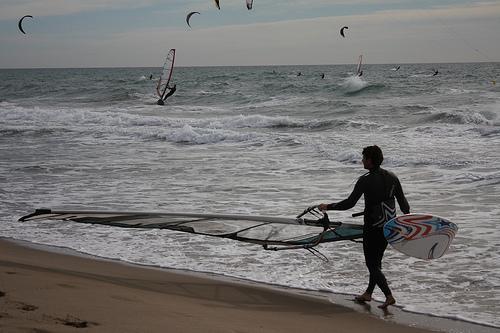How many people are walking on the beach?
Give a very brief answer. 1. 